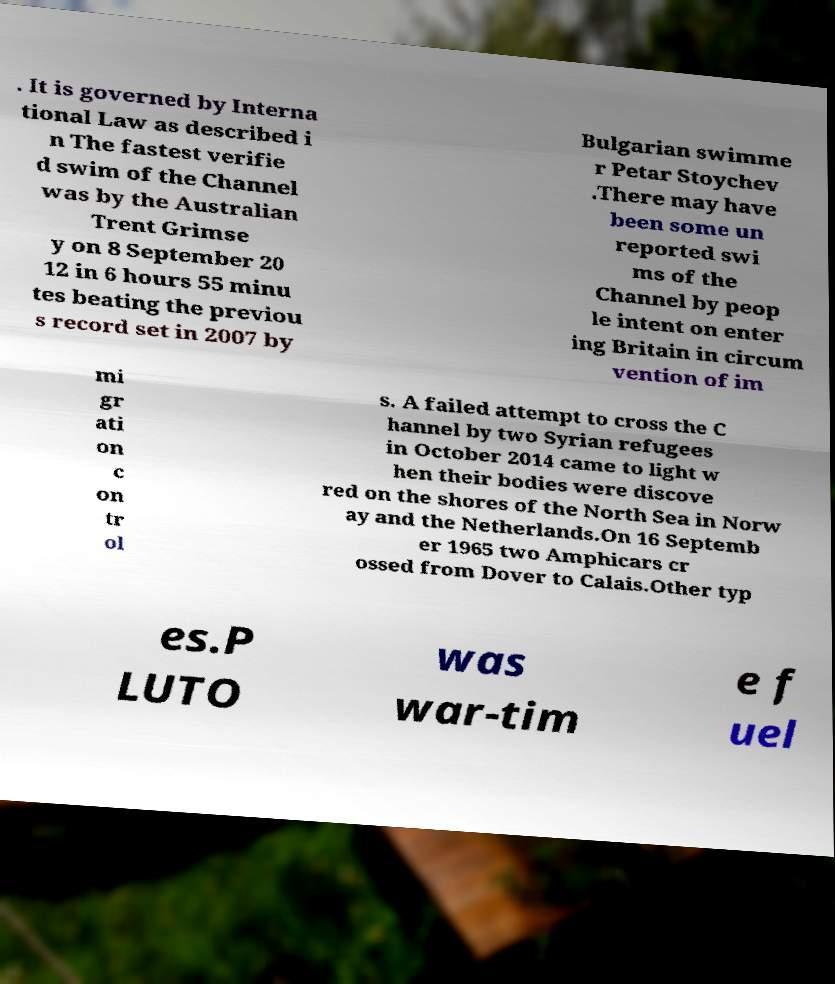There's text embedded in this image that I need extracted. Can you transcribe it verbatim? . It is governed by Interna tional Law as described i n The fastest verifie d swim of the Channel was by the Australian Trent Grimse y on 8 September 20 12 in 6 hours 55 minu tes beating the previou s record set in 2007 by Bulgarian swimme r Petar Stoychev .There may have been some un reported swi ms of the Channel by peop le intent on enter ing Britain in circum vention of im mi gr ati on c on tr ol s. A failed attempt to cross the C hannel by two Syrian refugees in October 2014 came to light w hen their bodies were discove red on the shores of the North Sea in Norw ay and the Netherlands.On 16 Septemb er 1965 two Amphicars cr ossed from Dover to Calais.Other typ es.P LUTO was war-tim e f uel 